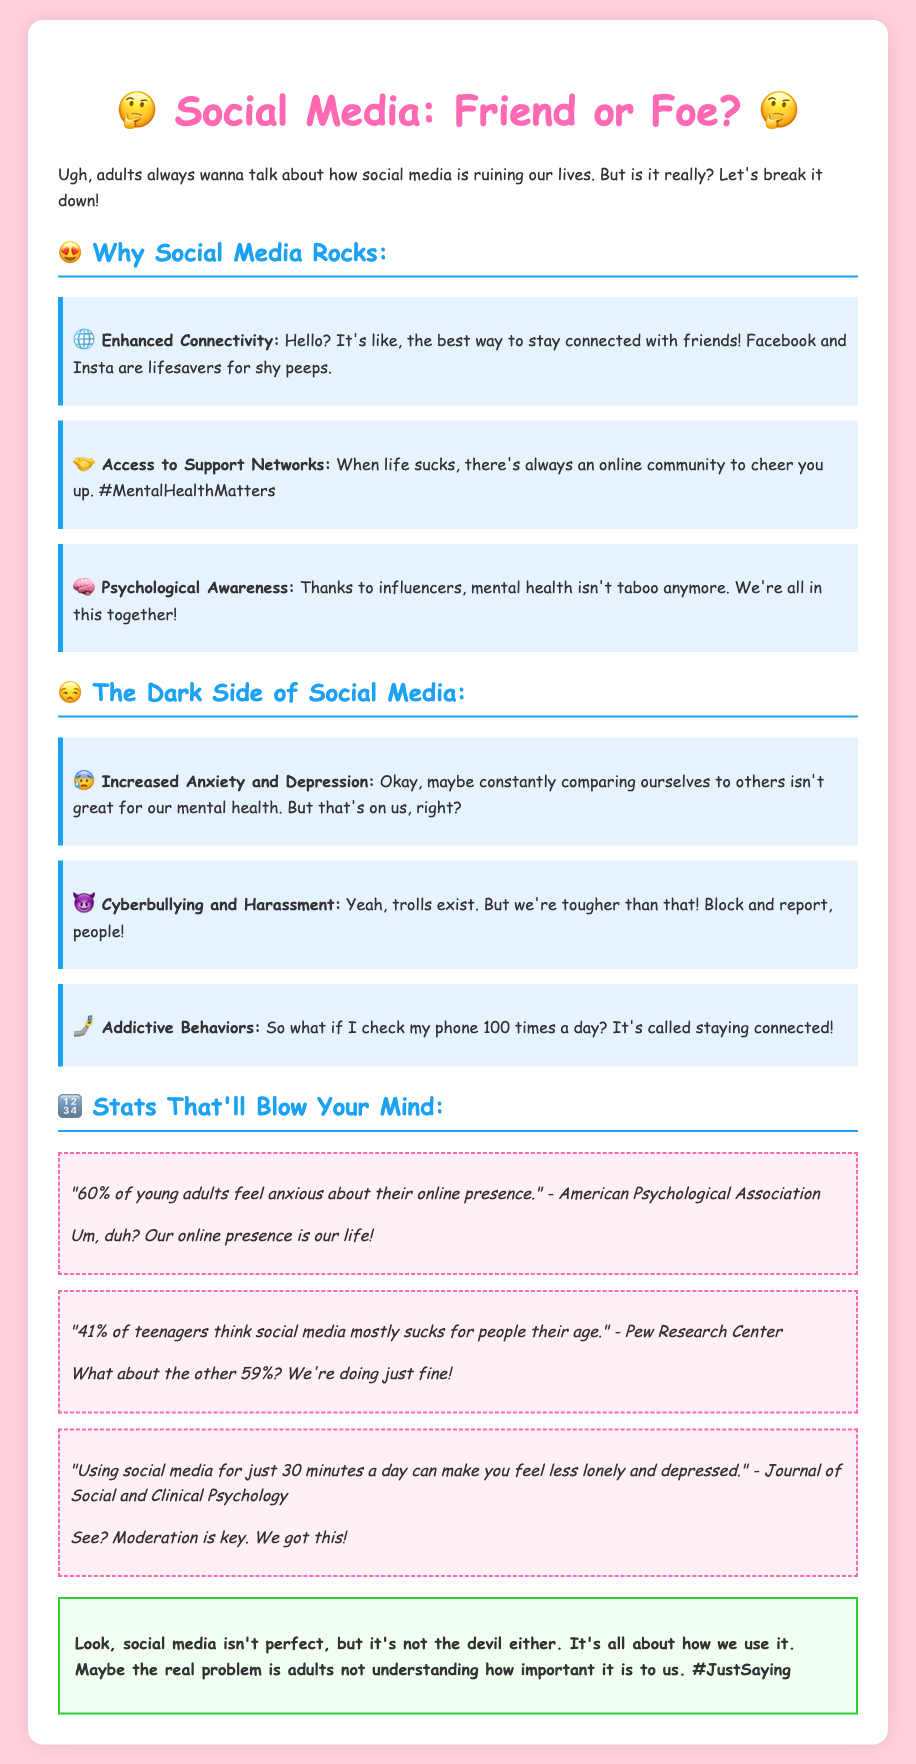What percentage of young adults feel anxious about their online presence? The document states that 60% of young adults feel anxious about their online presence.
Answer: 60% What is a positive effect of social media according to the document? The document mentions Enhanced Connectivity as a positive effect of social media.
Answer: Enhanced Connectivity What is the title of the document? The title of the document is "Social Media's Impact on Mental Health: A Teen's Perspective."
Answer: Social Media's Impact on Mental Health: A Teen's Perspective What percentage of teenagers think social media mostly sucks for people their age? The document indicates that 41% of teenagers think social media mostly sucks for people their age.
Answer: 41% According to the Journal of Social and Clinical Psychology, how long should you use social media to feel less lonely? The document states that using social media for just 30 minutes a day can have positive effects.
Answer: 30 minutes What does the conclusion suggest about social media? The conclusion suggests that social media isn't perfect, but it's not the devil either and depends on usage.
Answer: It's all about how we use it 